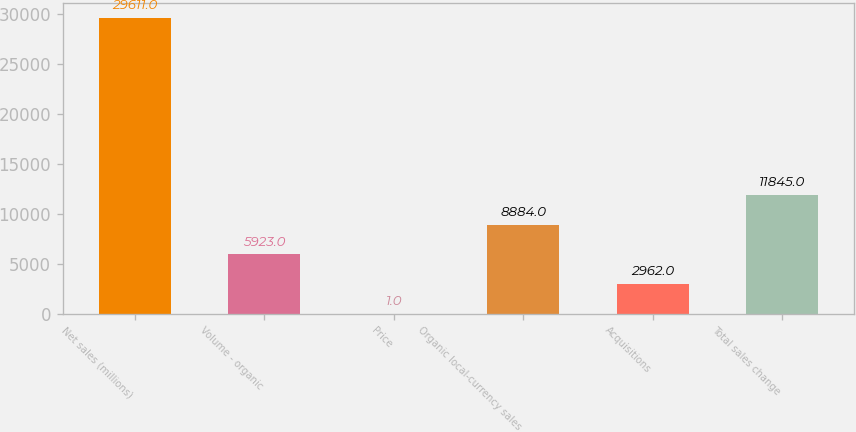<chart> <loc_0><loc_0><loc_500><loc_500><bar_chart><fcel>Net sales (millions)<fcel>Volume - organic<fcel>Price<fcel>Organic local-currency sales<fcel>Acquisitions<fcel>Total sales change<nl><fcel>29611<fcel>5923<fcel>1<fcel>8884<fcel>2962<fcel>11845<nl></chart> 